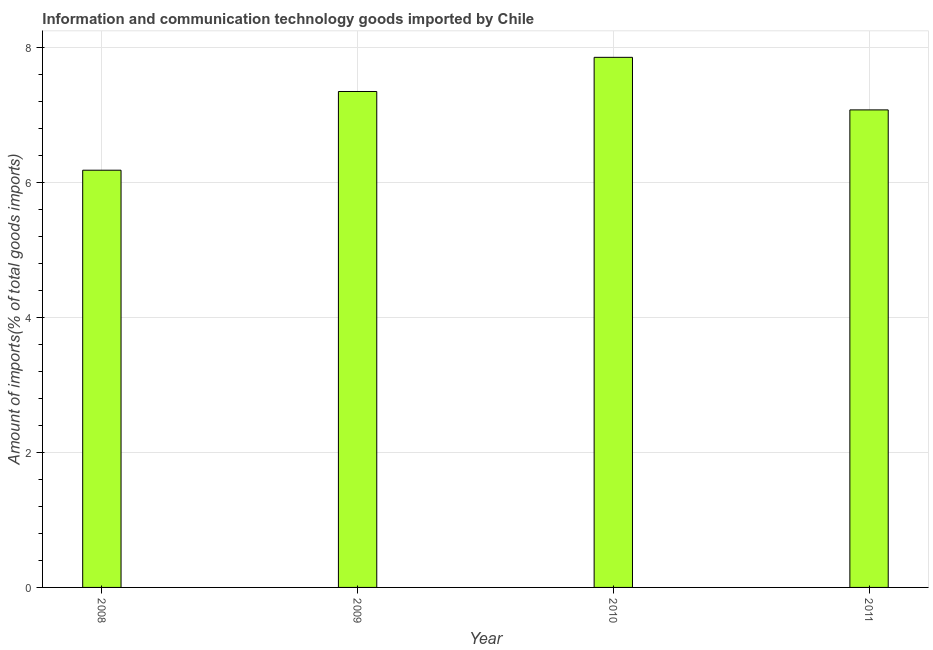What is the title of the graph?
Offer a terse response. Information and communication technology goods imported by Chile. What is the label or title of the X-axis?
Offer a very short reply. Year. What is the label or title of the Y-axis?
Offer a terse response. Amount of imports(% of total goods imports). What is the amount of ict goods imports in 2008?
Offer a very short reply. 6.18. Across all years, what is the maximum amount of ict goods imports?
Your answer should be very brief. 7.86. Across all years, what is the minimum amount of ict goods imports?
Ensure brevity in your answer.  6.18. In which year was the amount of ict goods imports maximum?
Offer a terse response. 2010. In which year was the amount of ict goods imports minimum?
Your answer should be compact. 2008. What is the sum of the amount of ict goods imports?
Make the answer very short. 28.46. What is the difference between the amount of ict goods imports in 2008 and 2011?
Provide a succinct answer. -0.89. What is the average amount of ict goods imports per year?
Your answer should be very brief. 7.12. What is the median amount of ict goods imports?
Provide a short and direct response. 7.21. In how many years, is the amount of ict goods imports greater than 4 %?
Make the answer very short. 4. Do a majority of the years between 2008 and 2010 (inclusive) have amount of ict goods imports greater than 5.2 %?
Make the answer very short. Yes. What is the ratio of the amount of ict goods imports in 2008 to that in 2010?
Your response must be concise. 0.79. Is the difference between the amount of ict goods imports in 2010 and 2011 greater than the difference between any two years?
Your response must be concise. No. What is the difference between the highest and the second highest amount of ict goods imports?
Offer a terse response. 0.51. What is the difference between the highest and the lowest amount of ict goods imports?
Ensure brevity in your answer.  1.67. In how many years, is the amount of ict goods imports greater than the average amount of ict goods imports taken over all years?
Your answer should be compact. 2. How many bars are there?
Give a very brief answer. 4. Are all the bars in the graph horizontal?
Offer a very short reply. No. What is the difference between two consecutive major ticks on the Y-axis?
Your answer should be very brief. 2. What is the Amount of imports(% of total goods imports) of 2008?
Your answer should be very brief. 6.18. What is the Amount of imports(% of total goods imports) of 2009?
Provide a short and direct response. 7.35. What is the Amount of imports(% of total goods imports) of 2010?
Your response must be concise. 7.86. What is the Amount of imports(% of total goods imports) of 2011?
Provide a short and direct response. 7.08. What is the difference between the Amount of imports(% of total goods imports) in 2008 and 2009?
Ensure brevity in your answer.  -1.17. What is the difference between the Amount of imports(% of total goods imports) in 2008 and 2010?
Your response must be concise. -1.67. What is the difference between the Amount of imports(% of total goods imports) in 2008 and 2011?
Give a very brief answer. -0.89. What is the difference between the Amount of imports(% of total goods imports) in 2009 and 2010?
Provide a succinct answer. -0.51. What is the difference between the Amount of imports(% of total goods imports) in 2009 and 2011?
Provide a succinct answer. 0.27. What is the difference between the Amount of imports(% of total goods imports) in 2010 and 2011?
Your answer should be very brief. 0.78. What is the ratio of the Amount of imports(% of total goods imports) in 2008 to that in 2009?
Your response must be concise. 0.84. What is the ratio of the Amount of imports(% of total goods imports) in 2008 to that in 2010?
Keep it short and to the point. 0.79. What is the ratio of the Amount of imports(% of total goods imports) in 2008 to that in 2011?
Your answer should be very brief. 0.87. What is the ratio of the Amount of imports(% of total goods imports) in 2009 to that in 2010?
Offer a terse response. 0.94. What is the ratio of the Amount of imports(% of total goods imports) in 2009 to that in 2011?
Give a very brief answer. 1.04. What is the ratio of the Amount of imports(% of total goods imports) in 2010 to that in 2011?
Offer a terse response. 1.11. 